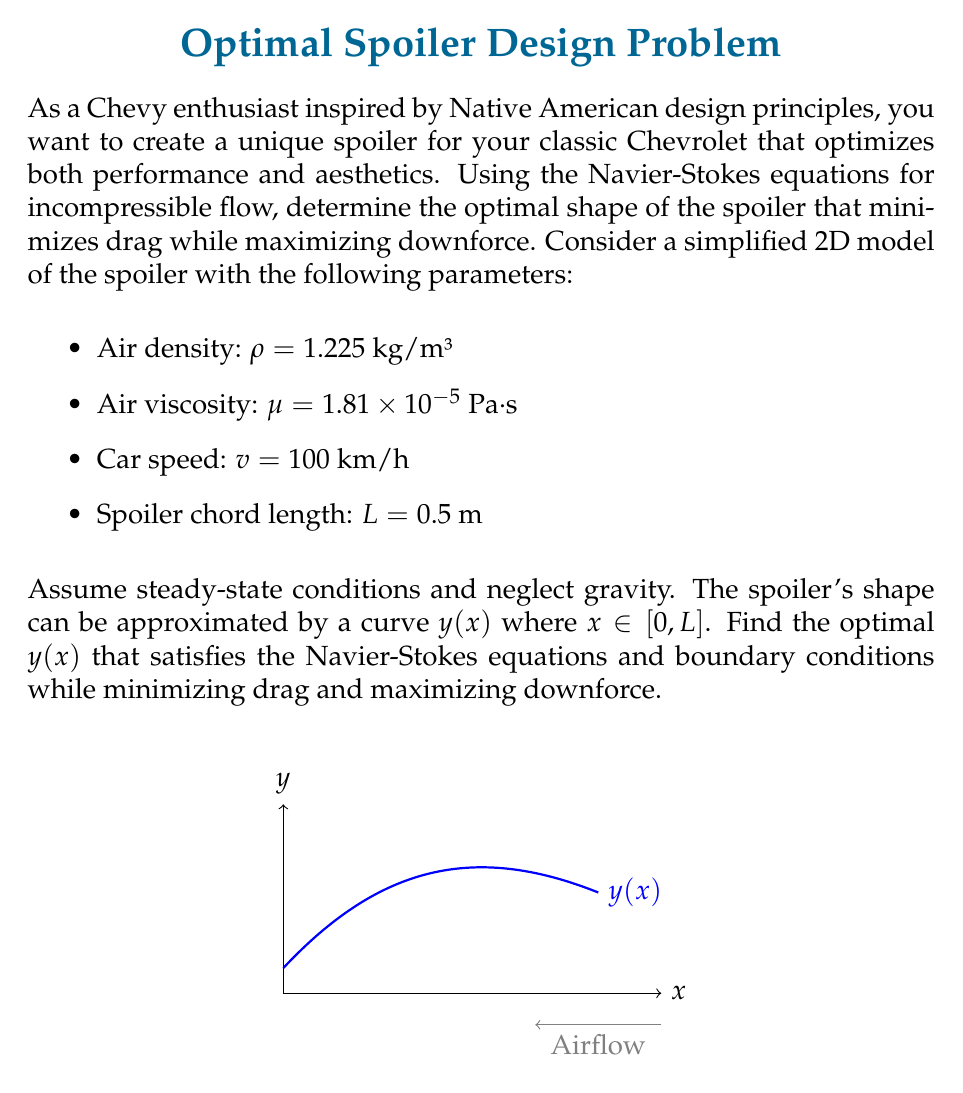Give your solution to this math problem. To solve this problem, we need to follow these steps:

1) First, we need to set up the Navier-Stokes equations for incompressible flow in 2D:

   $$\rho(\frac{\partial u}{\partial t} + u\frac{\partial u}{\partial x} + v\frac{\partial u}{\partial y}) = -\frac{\partial p}{\partial x} + \mu(\frac{\partial^2 u}{\partial x^2} + \frac{\partial^2 u}{\partial y^2})$$
   $$\rho(\frac{\partial v}{\partial t} + u\frac{\partial v}{\partial x} + v\frac{\partial v}{\partial y}) = -\frac{\partial p}{\partial y} + \mu(\frac{\partial^2 v}{\partial x^2} + \frac{\partial^2 v}{\partial y^2})$$

   With the continuity equation:
   $$\frac{\partial u}{\partial x} + \frac{\partial v}{\partial y} = 0$$

2) For steady-state conditions, we can eliminate the time derivatives:

   $$\rho(u\frac{\partial u}{\partial x} + v\frac{\partial u}{\partial y}) = -\frac{\partial p}{\partial x} + \mu(\frac{\partial^2 u}{\partial x^2} + \frac{\partial^2 u}{\partial y^2})$$
   $$\rho(u\frac{\partial v}{\partial x} + v\frac{\partial v}{\partial y}) = -\frac{\partial p}{\partial y} + \mu(\frac{\partial^2 v}{\partial x^2} + \frac{\partial^2 v}{\partial y^2})$$

3) We need to define boundary conditions:
   - No-slip condition at the spoiler surface: $u(x,y(x)) = v(x,y(x)) = 0$
   - Free-stream condition far from the spoiler: $u(x,\infty) = v$, $v(x,\infty) = 0$

4) To find the optimal shape $y(x)$, we need to minimize the drag force and maximize the downforce. These forces can be calculated by integrating the pressure and shear stress over the spoiler surface:

   $$F_D = \int_0^L (p\sin\theta + \tau\cos\theta) dx$$
   $$F_L = \int_0^L (p\cos\theta - \tau\sin\theta) dx$$

   Where $\theta$ is the angle between the spoiler surface and the x-axis at each point, and $\tau$ is the shear stress.

5) The problem now becomes an optimization problem. We need to find $y(x)$ that minimizes $F_D$ and maximizes $F_L$ while satisfying the Navier-Stokes equations and boundary conditions.

6) This is a complex problem that typically requires numerical methods to solve. We would use techniques such as computational fluid dynamics (CFD) combined with optimization algorithms like genetic algorithms or gradient-based methods.

7) The solution would likely result in a curved shape that smoothly transitions from the leading edge to the trailing edge, possibly with a slight upturn at the rear to increase downforce.

8) The exact shape would depend on the specific optimization criteria and constraints, which could include factors like manufacturability and aesthetic considerations inspired by Native American design principles.
Answer: Optimal $y(x)$ found through numerical solution of Navier-Stokes equations and optimization of drag and downforce integrals. 